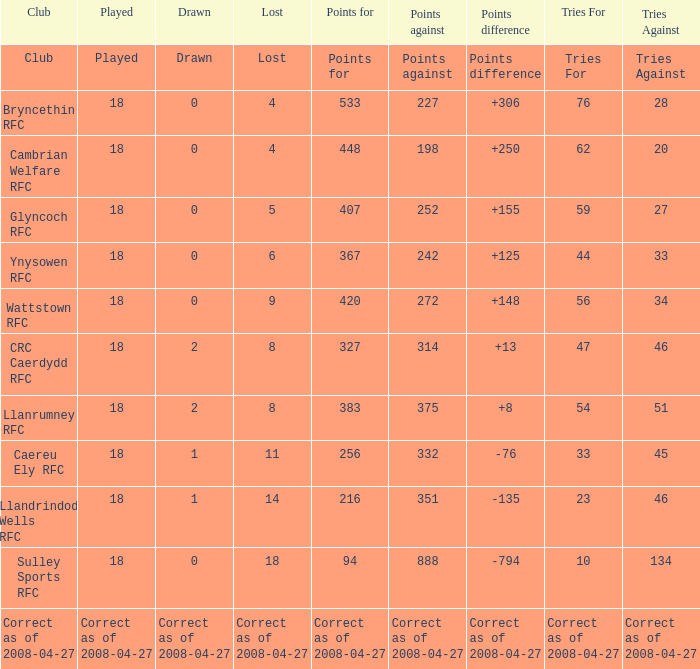What is the value for the item "Lost" when the value "Tries" is 47? 8.0. 